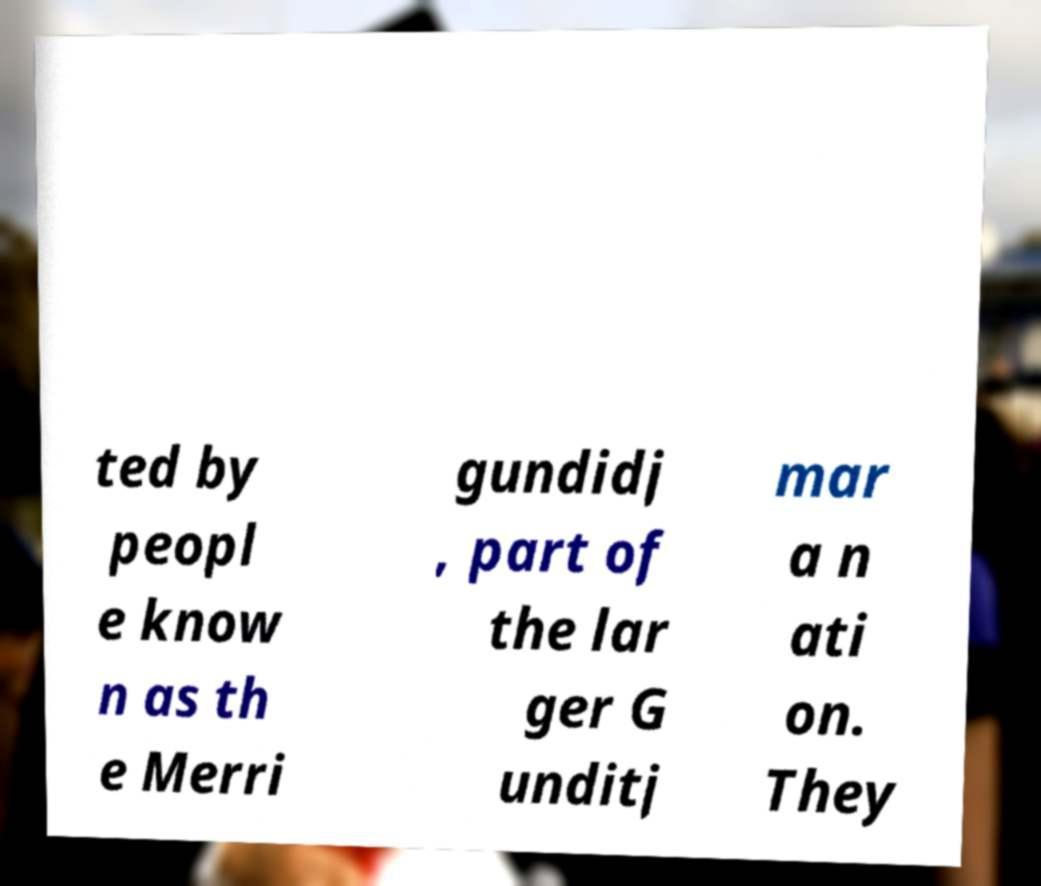Could you extract and type out the text from this image? ted by peopl e know n as th e Merri gundidj , part of the lar ger G unditj mar a n ati on. They 